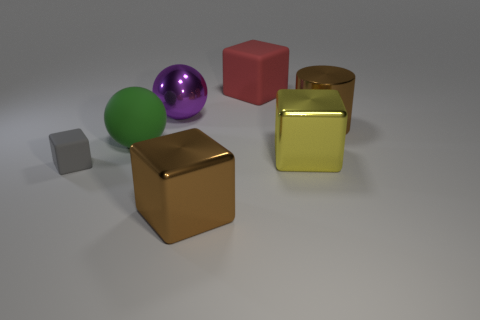The red object that is the same material as the big green sphere is what size?
Give a very brief answer. Large. There is a rubber thing that is behind the brown cylinder; does it have the same shape as the purple object?
Keep it short and to the point. No. The shiny block that is the same color as the metal cylinder is what size?
Your answer should be compact. Large. How many brown objects are big rubber balls or rubber blocks?
Offer a very short reply. 0. How many other objects are there of the same shape as the small gray matte thing?
Make the answer very short. 3. There is a large shiny thing that is both to the left of the large rubber block and in front of the large metallic ball; what is its shape?
Your answer should be very brief. Cube. There is a green matte sphere; are there any brown metal cubes on the left side of it?
Offer a terse response. No. The other rubber object that is the same shape as the large purple thing is what size?
Offer a very short reply. Large. Is there anything else that is the same size as the green rubber thing?
Your answer should be very brief. Yes. Is the shape of the tiny gray thing the same as the purple shiny thing?
Your response must be concise. No. 